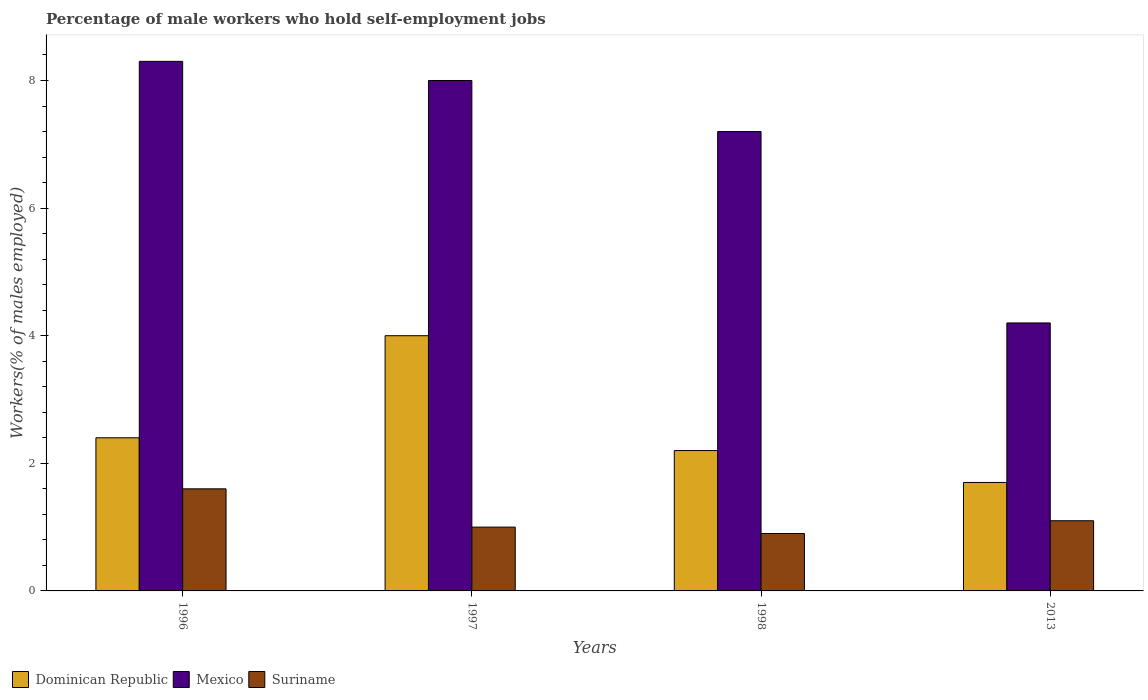How many different coloured bars are there?
Keep it short and to the point. 3. Are the number of bars per tick equal to the number of legend labels?
Give a very brief answer. Yes. Are the number of bars on each tick of the X-axis equal?
Provide a succinct answer. Yes. How many bars are there on the 1st tick from the left?
Give a very brief answer. 3. In how many cases, is the number of bars for a given year not equal to the number of legend labels?
Make the answer very short. 0. What is the percentage of self-employed male workers in Mexico in 2013?
Make the answer very short. 4.2. Across all years, what is the maximum percentage of self-employed male workers in Mexico?
Make the answer very short. 8.3. Across all years, what is the minimum percentage of self-employed male workers in Mexico?
Your answer should be compact. 4.2. In which year was the percentage of self-employed male workers in Dominican Republic minimum?
Give a very brief answer. 2013. What is the total percentage of self-employed male workers in Mexico in the graph?
Offer a terse response. 27.7. What is the difference between the percentage of self-employed male workers in Dominican Republic in 1997 and that in 2013?
Make the answer very short. 2.3. What is the difference between the percentage of self-employed male workers in Dominican Republic in 2013 and the percentage of self-employed male workers in Suriname in 1996?
Make the answer very short. 0.1. What is the average percentage of self-employed male workers in Mexico per year?
Provide a succinct answer. 6.92. In the year 1996, what is the difference between the percentage of self-employed male workers in Dominican Republic and percentage of self-employed male workers in Mexico?
Your answer should be compact. -5.9. What is the ratio of the percentage of self-employed male workers in Mexico in 1996 to that in 1998?
Your answer should be compact. 1.15. Is the difference between the percentage of self-employed male workers in Dominican Republic in 1997 and 1998 greater than the difference between the percentage of self-employed male workers in Mexico in 1997 and 1998?
Offer a very short reply. Yes. What is the difference between the highest and the lowest percentage of self-employed male workers in Dominican Republic?
Ensure brevity in your answer.  2.3. Is the sum of the percentage of self-employed male workers in Suriname in 1996 and 1998 greater than the maximum percentage of self-employed male workers in Mexico across all years?
Ensure brevity in your answer.  No. What does the 3rd bar from the left in 1998 represents?
Offer a terse response. Suriname. What does the 3rd bar from the right in 1998 represents?
Keep it short and to the point. Dominican Republic. Are the values on the major ticks of Y-axis written in scientific E-notation?
Provide a succinct answer. No. Does the graph contain grids?
Offer a very short reply. No. Where does the legend appear in the graph?
Provide a succinct answer. Bottom left. How are the legend labels stacked?
Keep it short and to the point. Horizontal. What is the title of the graph?
Offer a terse response. Percentage of male workers who hold self-employment jobs. What is the label or title of the Y-axis?
Provide a short and direct response. Workers(% of males employed). What is the Workers(% of males employed) in Dominican Republic in 1996?
Keep it short and to the point. 2.4. What is the Workers(% of males employed) in Mexico in 1996?
Provide a short and direct response. 8.3. What is the Workers(% of males employed) of Suriname in 1996?
Your answer should be very brief. 1.6. What is the Workers(% of males employed) of Dominican Republic in 1997?
Offer a very short reply. 4. What is the Workers(% of males employed) in Dominican Republic in 1998?
Your response must be concise. 2.2. What is the Workers(% of males employed) in Mexico in 1998?
Make the answer very short. 7.2. What is the Workers(% of males employed) in Suriname in 1998?
Ensure brevity in your answer.  0.9. What is the Workers(% of males employed) in Dominican Republic in 2013?
Provide a succinct answer. 1.7. What is the Workers(% of males employed) of Mexico in 2013?
Your response must be concise. 4.2. What is the Workers(% of males employed) of Suriname in 2013?
Make the answer very short. 1.1. Across all years, what is the maximum Workers(% of males employed) of Mexico?
Make the answer very short. 8.3. Across all years, what is the maximum Workers(% of males employed) in Suriname?
Keep it short and to the point. 1.6. Across all years, what is the minimum Workers(% of males employed) in Dominican Republic?
Offer a terse response. 1.7. Across all years, what is the minimum Workers(% of males employed) of Mexico?
Make the answer very short. 4.2. Across all years, what is the minimum Workers(% of males employed) of Suriname?
Offer a terse response. 0.9. What is the total Workers(% of males employed) of Mexico in the graph?
Your response must be concise. 27.7. What is the total Workers(% of males employed) of Suriname in the graph?
Offer a terse response. 4.6. What is the difference between the Workers(% of males employed) of Dominican Republic in 1996 and that in 1997?
Keep it short and to the point. -1.6. What is the difference between the Workers(% of males employed) of Mexico in 1996 and that in 1997?
Make the answer very short. 0.3. What is the difference between the Workers(% of males employed) in Suriname in 1996 and that in 1997?
Provide a succinct answer. 0.6. What is the difference between the Workers(% of males employed) of Dominican Republic in 1996 and that in 1998?
Your answer should be very brief. 0.2. What is the difference between the Workers(% of males employed) in Suriname in 1996 and that in 1998?
Provide a short and direct response. 0.7. What is the difference between the Workers(% of males employed) of Suriname in 1997 and that in 1998?
Your answer should be very brief. 0.1. What is the difference between the Workers(% of males employed) in Dominican Republic in 1997 and that in 2013?
Ensure brevity in your answer.  2.3. What is the difference between the Workers(% of males employed) in Dominican Republic in 1998 and that in 2013?
Provide a succinct answer. 0.5. What is the difference between the Workers(% of males employed) of Mexico in 1998 and that in 2013?
Your answer should be compact. 3. What is the difference between the Workers(% of males employed) in Dominican Republic in 1996 and the Workers(% of males employed) in Suriname in 1997?
Offer a very short reply. 1.4. What is the difference between the Workers(% of males employed) of Mexico in 1996 and the Workers(% of males employed) of Suriname in 2013?
Offer a terse response. 7.2. What is the difference between the Workers(% of males employed) in Dominican Republic in 1997 and the Workers(% of males employed) in Suriname in 2013?
Offer a very short reply. 2.9. What is the difference between the Workers(% of males employed) in Dominican Republic in 1998 and the Workers(% of males employed) in Mexico in 2013?
Provide a succinct answer. -2. What is the difference between the Workers(% of males employed) in Dominican Republic in 1998 and the Workers(% of males employed) in Suriname in 2013?
Your answer should be very brief. 1.1. What is the difference between the Workers(% of males employed) of Mexico in 1998 and the Workers(% of males employed) of Suriname in 2013?
Offer a terse response. 6.1. What is the average Workers(% of males employed) in Dominican Republic per year?
Provide a short and direct response. 2.58. What is the average Workers(% of males employed) in Mexico per year?
Offer a very short reply. 6.92. What is the average Workers(% of males employed) of Suriname per year?
Give a very brief answer. 1.15. In the year 1996, what is the difference between the Workers(% of males employed) in Dominican Republic and Workers(% of males employed) in Mexico?
Ensure brevity in your answer.  -5.9. In the year 1996, what is the difference between the Workers(% of males employed) in Dominican Republic and Workers(% of males employed) in Suriname?
Your answer should be compact. 0.8. In the year 1996, what is the difference between the Workers(% of males employed) of Mexico and Workers(% of males employed) of Suriname?
Keep it short and to the point. 6.7. In the year 1997, what is the difference between the Workers(% of males employed) in Dominican Republic and Workers(% of males employed) in Mexico?
Make the answer very short. -4. In the year 1997, what is the difference between the Workers(% of males employed) of Dominican Republic and Workers(% of males employed) of Suriname?
Offer a terse response. 3. In the year 1997, what is the difference between the Workers(% of males employed) of Mexico and Workers(% of males employed) of Suriname?
Ensure brevity in your answer.  7. In the year 1998, what is the difference between the Workers(% of males employed) of Dominican Republic and Workers(% of males employed) of Suriname?
Provide a short and direct response. 1.3. In the year 2013, what is the difference between the Workers(% of males employed) of Mexico and Workers(% of males employed) of Suriname?
Provide a succinct answer. 3.1. What is the ratio of the Workers(% of males employed) of Mexico in 1996 to that in 1997?
Your answer should be compact. 1.04. What is the ratio of the Workers(% of males employed) in Suriname in 1996 to that in 1997?
Your response must be concise. 1.6. What is the ratio of the Workers(% of males employed) of Dominican Republic in 1996 to that in 1998?
Your answer should be compact. 1.09. What is the ratio of the Workers(% of males employed) of Mexico in 1996 to that in 1998?
Give a very brief answer. 1.15. What is the ratio of the Workers(% of males employed) of Suriname in 1996 to that in 1998?
Offer a terse response. 1.78. What is the ratio of the Workers(% of males employed) of Dominican Republic in 1996 to that in 2013?
Provide a short and direct response. 1.41. What is the ratio of the Workers(% of males employed) in Mexico in 1996 to that in 2013?
Keep it short and to the point. 1.98. What is the ratio of the Workers(% of males employed) of Suriname in 1996 to that in 2013?
Provide a succinct answer. 1.45. What is the ratio of the Workers(% of males employed) in Dominican Republic in 1997 to that in 1998?
Provide a succinct answer. 1.82. What is the ratio of the Workers(% of males employed) in Mexico in 1997 to that in 1998?
Provide a succinct answer. 1.11. What is the ratio of the Workers(% of males employed) in Dominican Republic in 1997 to that in 2013?
Give a very brief answer. 2.35. What is the ratio of the Workers(% of males employed) of Mexico in 1997 to that in 2013?
Offer a very short reply. 1.9. What is the ratio of the Workers(% of males employed) in Suriname in 1997 to that in 2013?
Provide a succinct answer. 0.91. What is the ratio of the Workers(% of males employed) of Dominican Republic in 1998 to that in 2013?
Your response must be concise. 1.29. What is the ratio of the Workers(% of males employed) of Mexico in 1998 to that in 2013?
Offer a terse response. 1.71. What is the ratio of the Workers(% of males employed) of Suriname in 1998 to that in 2013?
Your response must be concise. 0.82. What is the difference between the highest and the second highest Workers(% of males employed) in Mexico?
Ensure brevity in your answer.  0.3. What is the difference between the highest and the second highest Workers(% of males employed) of Suriname?
Ensure brevity in your answer.  0.5. What is the difference between the highest and the lowest Workers(% of males employed) of Dominican Republic?
Your answer should be very brief. 2.3. What is the difference between the highest and the lowest Workers(% of males employed) in Suriname?
Offer a terse response. 0.7. 